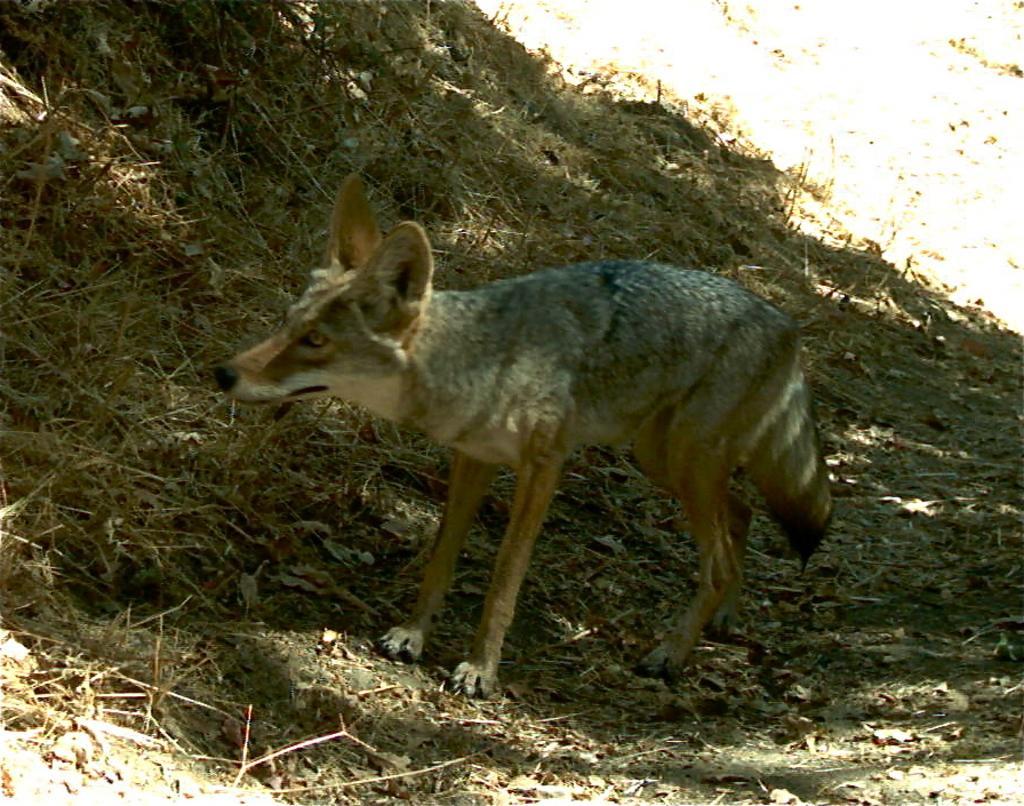How would you summarize this image in a sentence or two? In this image we can see animal and dried grass. 